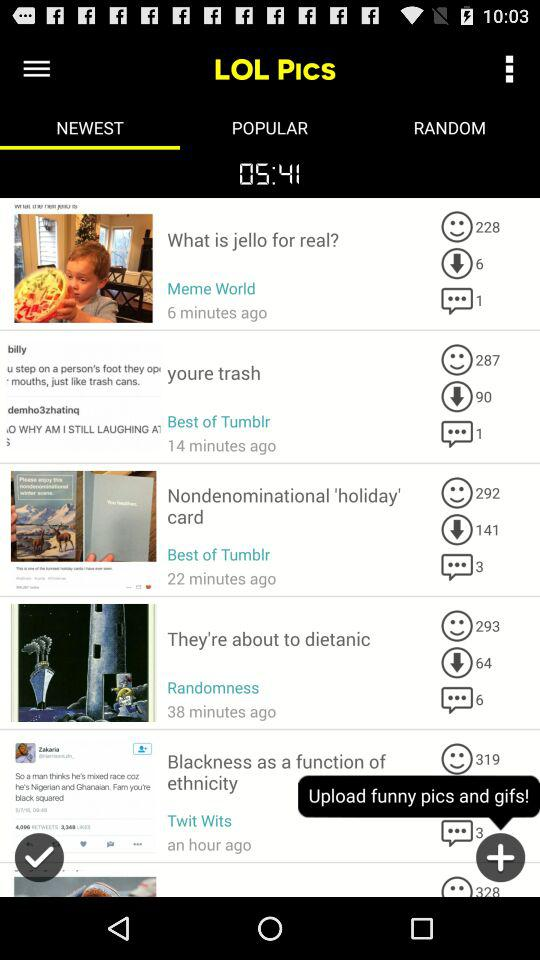How many minutes ago was "What is jello for real?" post updated? The post was updated 6 minutes ago. 